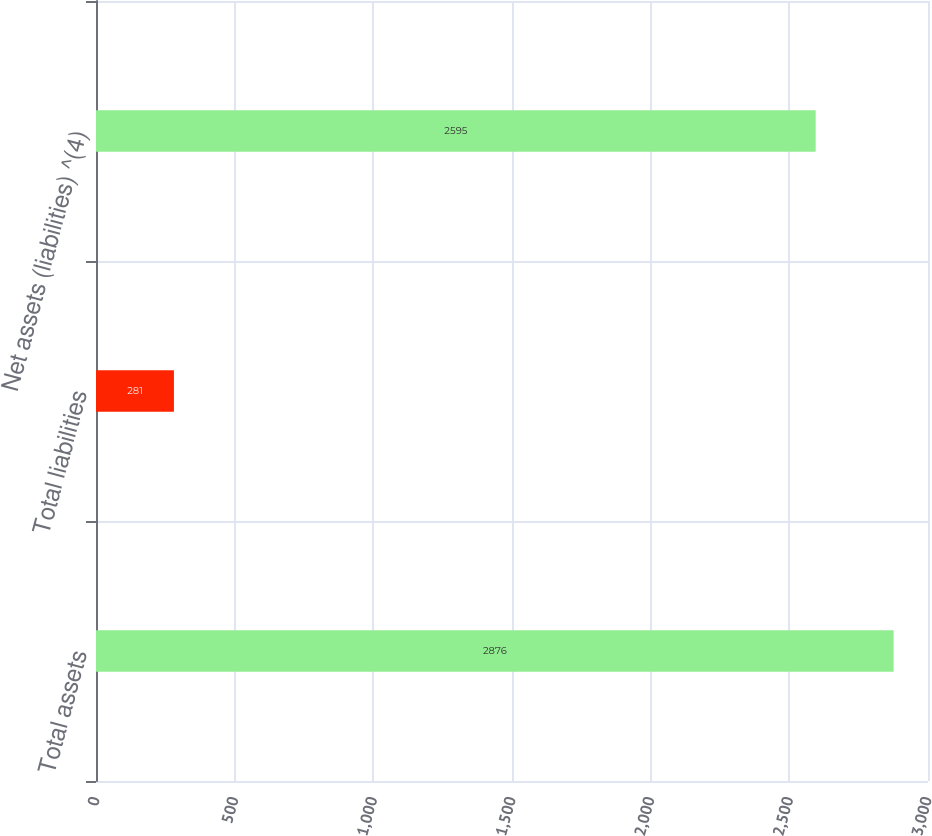<chart> <loc_0><loc_0><loc_500><loc_500><bar_chart><fcel>Total assets<fcel>Total liabilities<fcel>Net assets (liabilities) ^(4)<nl><fcel>2876<fcel>281<fcel>2595<nl></chart> 